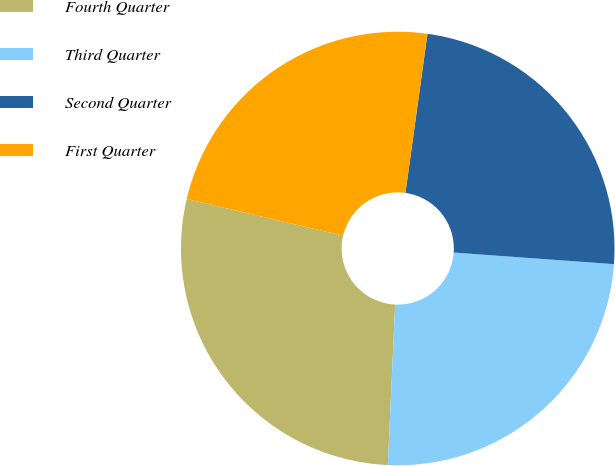Convert chart to OTSL. <chart><loc_0><loc_0><loc_500><loc_500><pie_chart><fcel>Fourth Quarter<fcel>Third Quarter<fcel>Second Quarter<fcel>First Quarter<nl><fcel>27.94%<fcel>24.58%<fcel>23.96%<fcel>23.52%<nl></chart> 